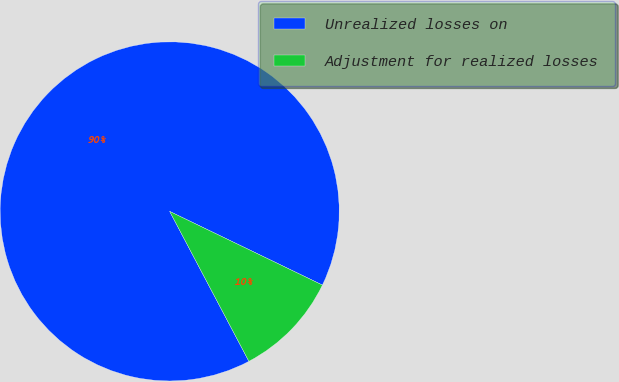<chart> <loc_0><loc_0><loc_500><loc_500><pie_chart><fcel>Unrealized losses on<fcel>Adjustment for realized losses<nl><fcel>89.89%<fcel>10.11%<nl></chart> 